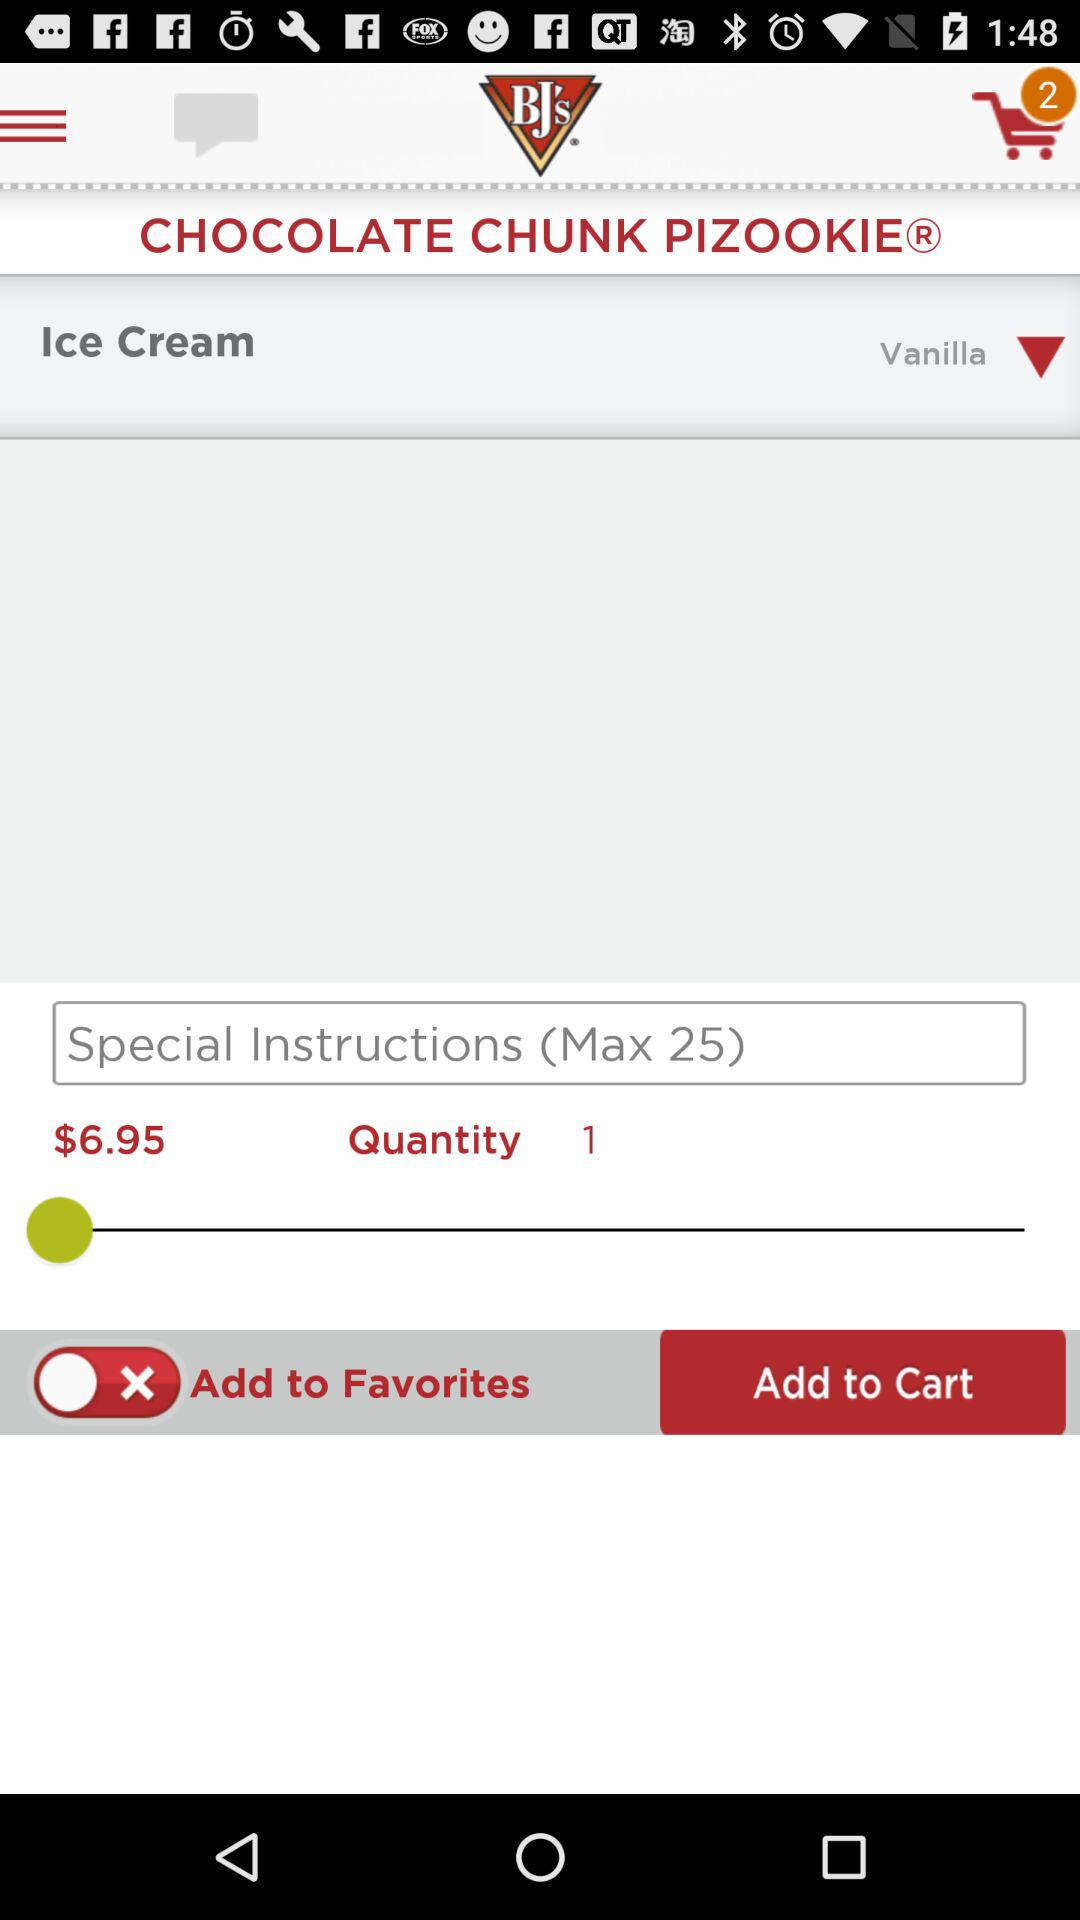What is the price of the "CHOCOLATE CHUNK PIZOOKIE"? The price of the "CHOCOLATE CHUNK PIZOOKIE" is $6.95. 